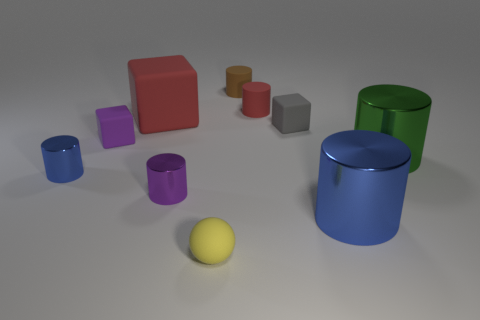Add 7 cyan matte blocks. How many cyan matte blocks exist? 7 Subtract all blue cylinders. How many cylinders are left? 4 Subtract all small rubber blocks. How many blocks are left? 1 Subtract 1 yellow spheres. How many objects are left? 9 Subtract all cylinders. How many objects are left? 4 Subtract 2 cylinders. How many cylinders are left? 4 Subtract all cyan cubes. Subtract all yellow spheres. How many cubes are left? 3 Subtract all purple spheres. How many brown cubes are left? 0 Subtract all small purple matte objects. Subtract all small brown matte things. How many objects are left? 8 Add 4 tiny purple shiny things. How many tiny purple shiny things are left? 5 